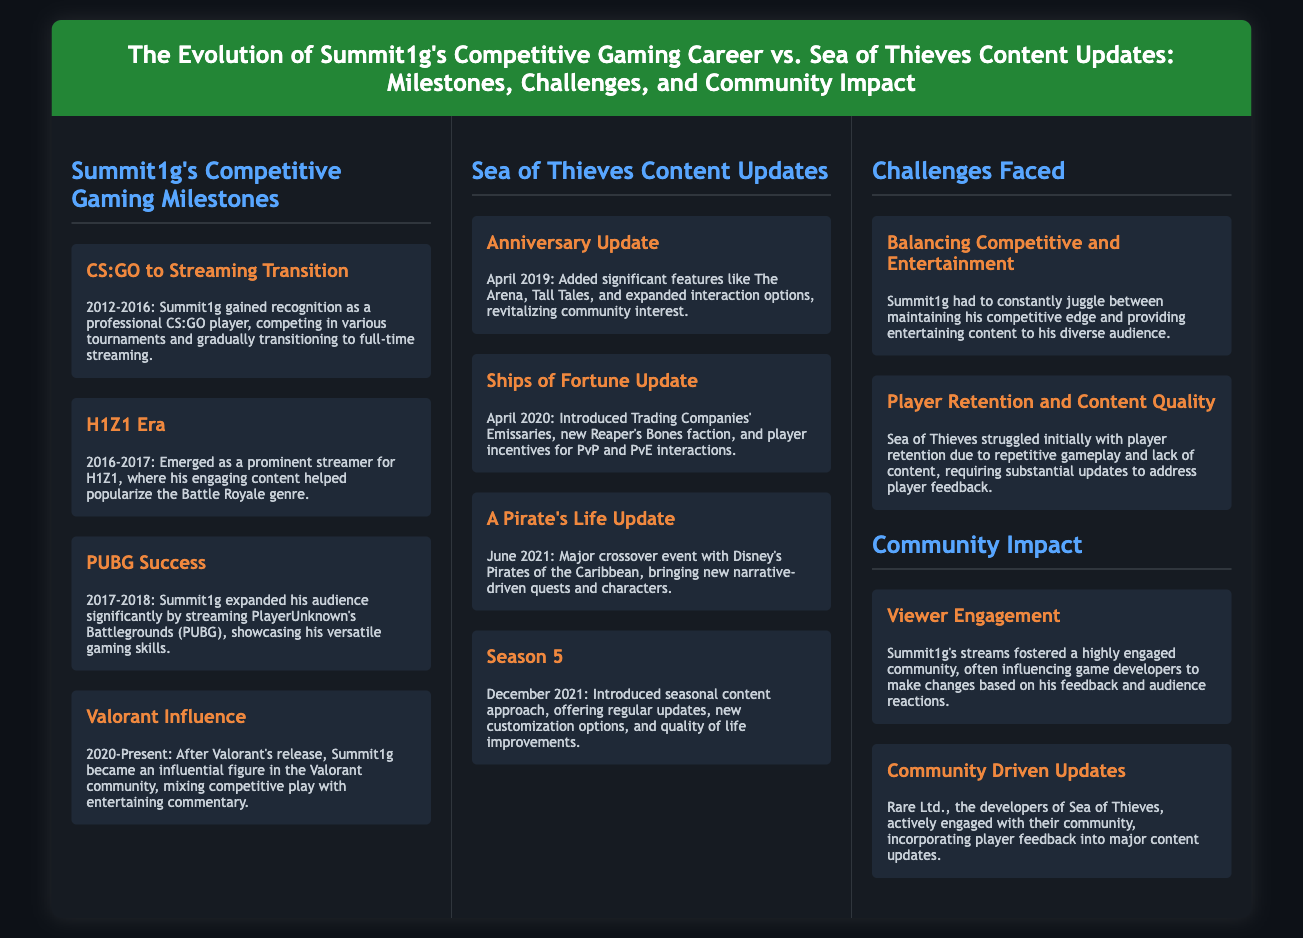what year did Summit1g transition from CS:GO to streaming? The document states that Summit1g gained recognition as a professional CS:GO player from 2012 to 2016, during which he gradually transitioned to full-time streaming.
Answer: 2016 which major crossover event was introduced in June 2021? The document specifies that June 2021 saw the introduction of the A Pirate's Life Update, which was a major crossover event with Disney's Pirates of the Caribbean.
Answer: A Pirate's Life what significant feature was added in the April 2019 Anniversary Update? The document highlights that the Anniversary Update added significant features like The Arena, Tall Tales, and expanded interaction options.
Answer: The Arena what challenge did Sea of Thieves face regarding gameplay? The document mentions that Sea of Thieves struggled initially with player retention due to repetitive gameplay and lack of content.
Answer: Player retention who is an influential figure in the Valorant community since its release? The document states that Summit1g became an influential figure in the Valorant community after its release, mixing competitive play with entertaining commentary.
Answer: Summit1g what community-driven initiative did Rare Ltd. engage in for Sea of Thieves? The document states that Rare Ltd. actively engaged with their community, incorporating player feedback into major content updates.
Answer: Player feedback what major update introduced player incentives for PvP and PvE interactions? The document notes that the Ships of Fortune Update introduced Trading Companies' Emissaries and player incentives for PvP and PvE interactions.
Answer: Ships of Fortune how long did Summit1g's H1Z1 era last? The document states that Summit1g emerged as a prominent streamer for H1Z1 from 2016 to 2017.
Answer: 1 year 